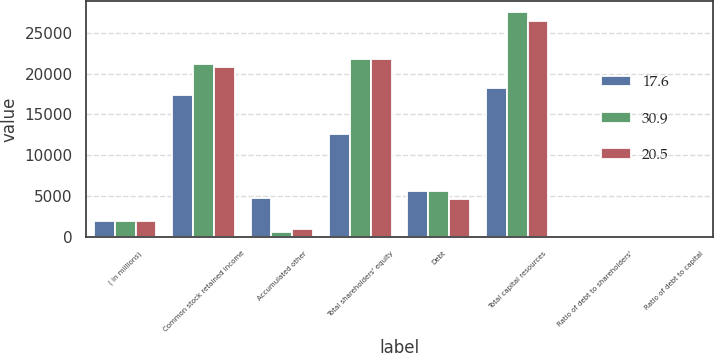Convert chart to OTSL. <chart><loc_0><loc_0><loc_500><loc_500><stacked_bar_chart><ecel><fcel>( in millions)<fcel>Common stock retained income<fcel>Accumulated other<fcel>Total shareholders' equity<fcel>Debt<fcel>Total capital resources<fcel>Ratio of debt to shareholders'<fcel>Ratio of debt to capital<nl><fcel>17.6<fcel>2008<fcel>17442<fcel>4801<fcel>12641<fcel>5659<fcel>18300<fcel>44.8<fcel>30.9<nl><fcel>30.9<fcel>2007<fcel>21228<fcel>623<fcel>21851<fcel>5640<fcel>27491<fcel>25.8<fcel>20.5<nl><fcel>20.5<fcel>2006<fcel>20855<fcel>991<fcel>21846<fcel>4662<fcel>26508<fcel>21.3<fcel>17.6<nl></chart> 